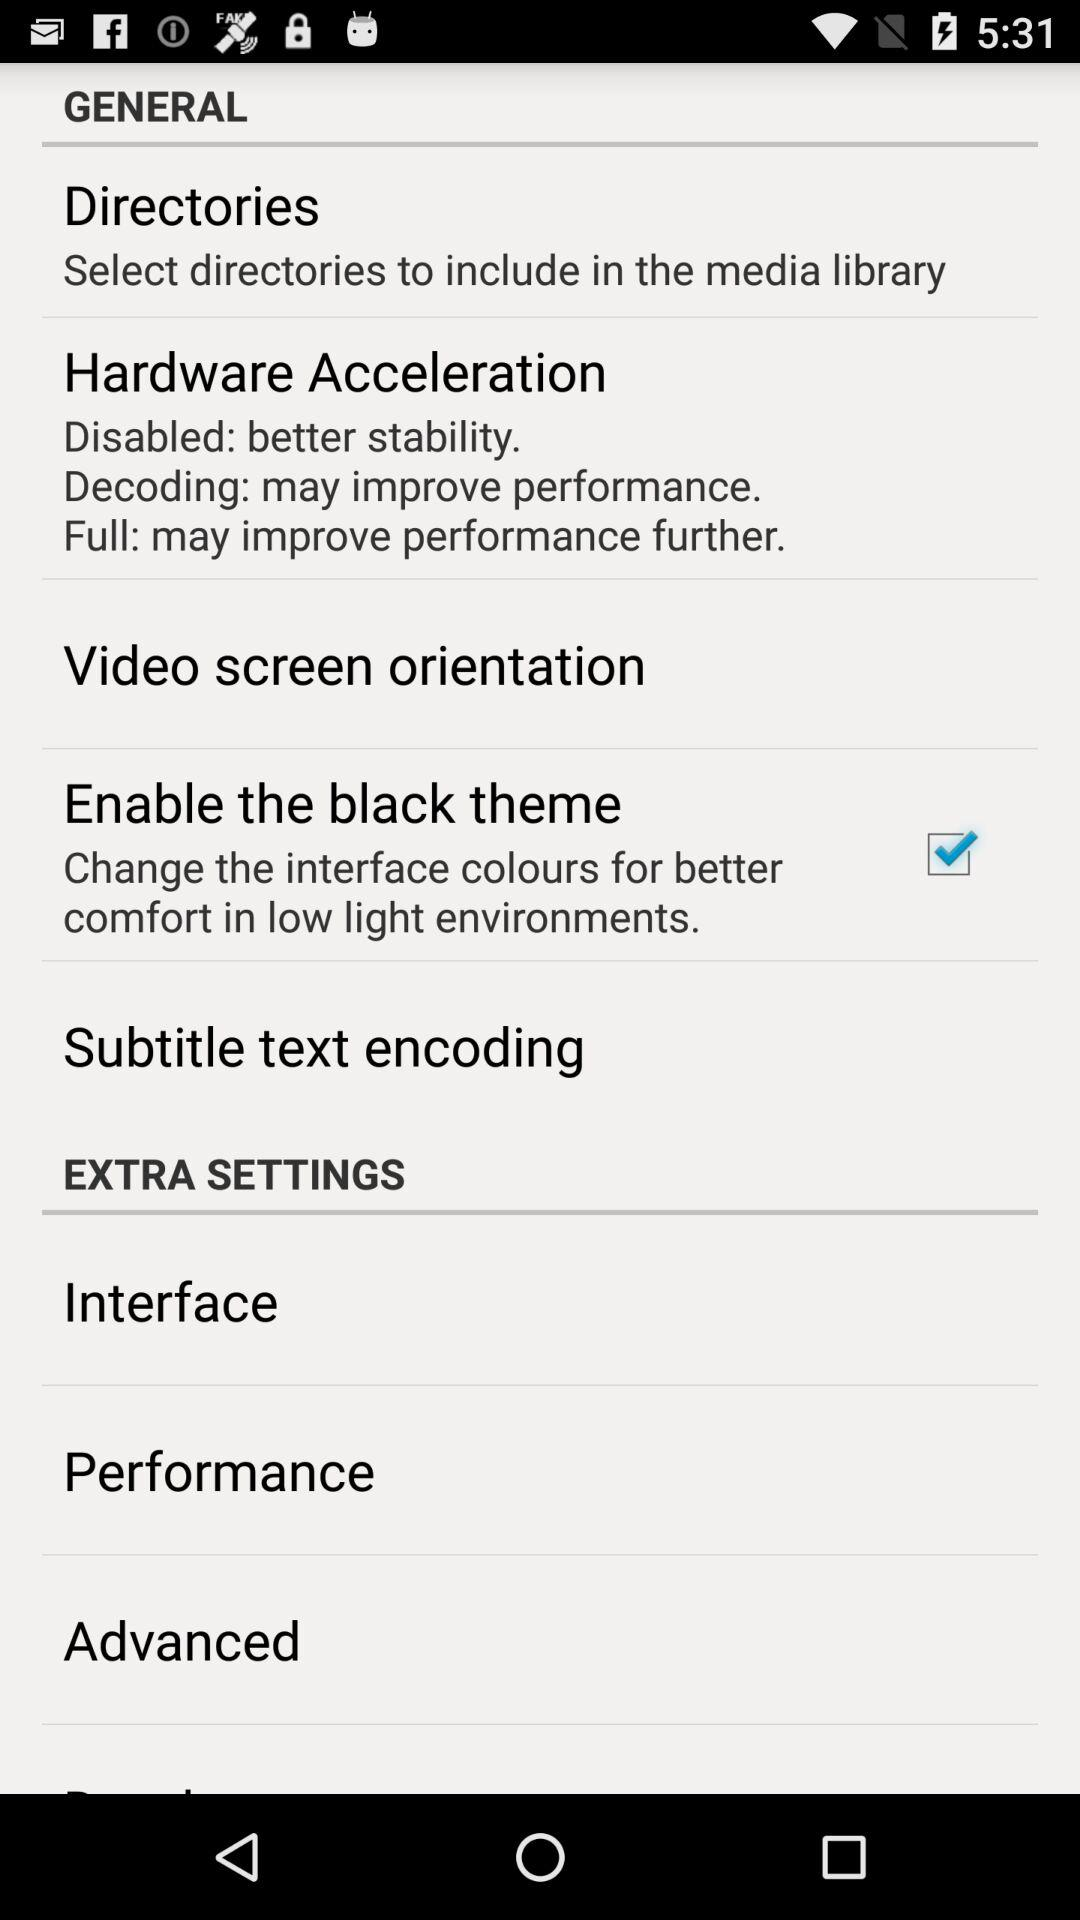What is the status of the "Enable the black theme"? The status is on. 